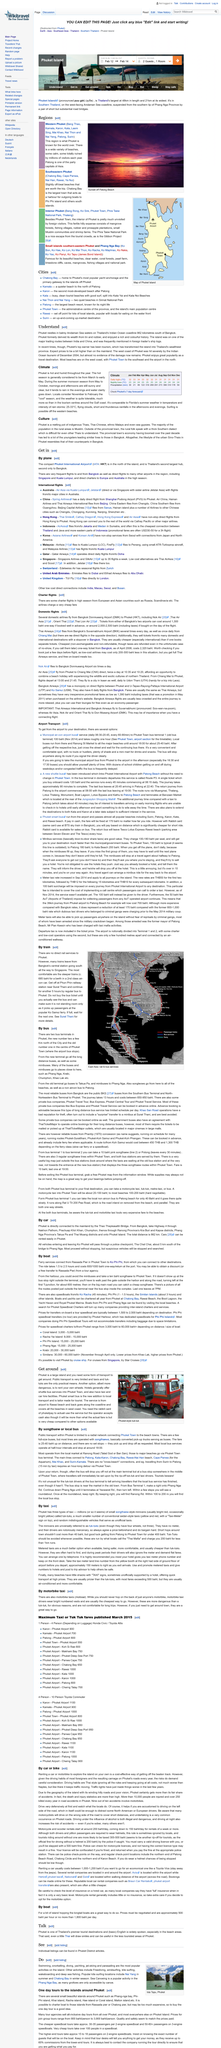Highlight a few significant elements in this photo. Yes, it is possible to surf off the western beaches of Phuket. The climate of Phuket is generally hot and humid throughout the year. The summer monsoon season in Phuket typically runs from May to October, during which time the island experiences heavy rainfall and strong winds. 